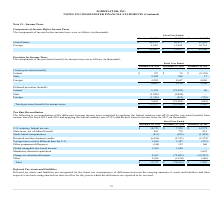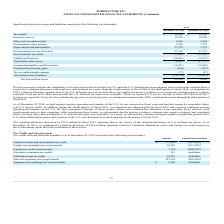According to Formfactor's financial document, What was the valuation allowance maintained from fourth quarter of fiscal 2009 to the third quarter of fiscal 2018? According to the financial document, 100%. The relevant text states: "the third quarter of fiscal 2018, we maintained a 100% valuation allowance against most of our U.S. deferred tax assets because there was insufficient posi..." Also, What was the amount of valuation allowance decrease in fiscal 2018? According to the financial document, $75.8 million. The relevant text states: "The valuation allowance decreased by $75.8 million in fiscal 2018, primarily due to the release of the valuation allowance on U.S. deferred tax assets...." Also, What were the tax credits in 2019 and 2018 respectively? The document shows two values: 44,696 and 39,586 (in thousands). From the document: "Tax credits $ 44,696 $ 39,586 Tax credits $ 44,696 $ 39,586..." Also, can you calculate: What is the change in the Tax credits from 2018 to 2019? Based on the calculation: 44,696 - 39,586, the result is 5110 (in thousands). This is based on the information: "Tax credits $ 44,696 $ 39,586 Tax credits $ 44,696 $ 39,586..." The key data points involved are: 39,586, 44,696. Also, can you calculate: What is the average Inventory reserve for 2018 and 2019? To answer this question, I need to perform calculations using the financial data. The calculation is: (12,350 + 10,850) / 2, which equals 11600 (in thousands). This is based on the information: "Inventory reserve 12,350 10,850 Inventory reserve 12,350 10,850..." The key data points involved are: 10,850, 12,350. Additionally, In which years is the Other reserves and accruals greater than 5,000 thousand? The document shows two values: 2019 and 2018. Locate and analyze the other reserves and accruals in row 5. From the document: "December 28, 2019 December 29, 2018 December 30, 2017 December 28, 2019 December 29, 2018 December 30, 2017..." 